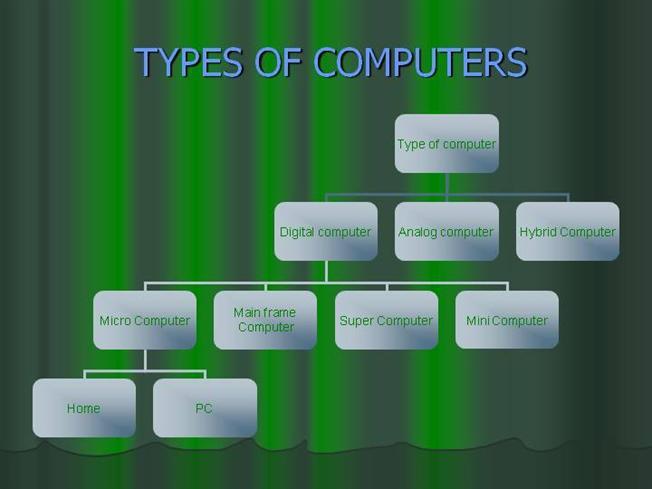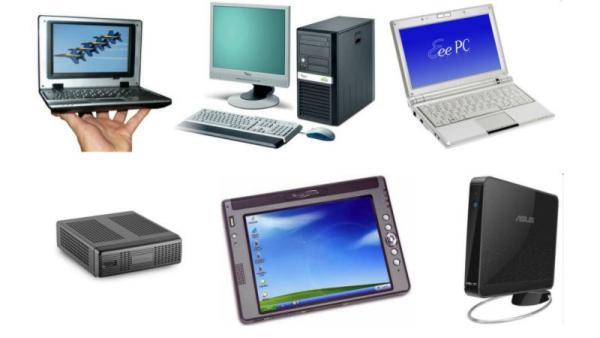The first image is the image on the left, the second image is the image on the right. Considering the images on both sides, is "A laptop is shown with black background in one of the images." valid? Answer yes or no. No. 